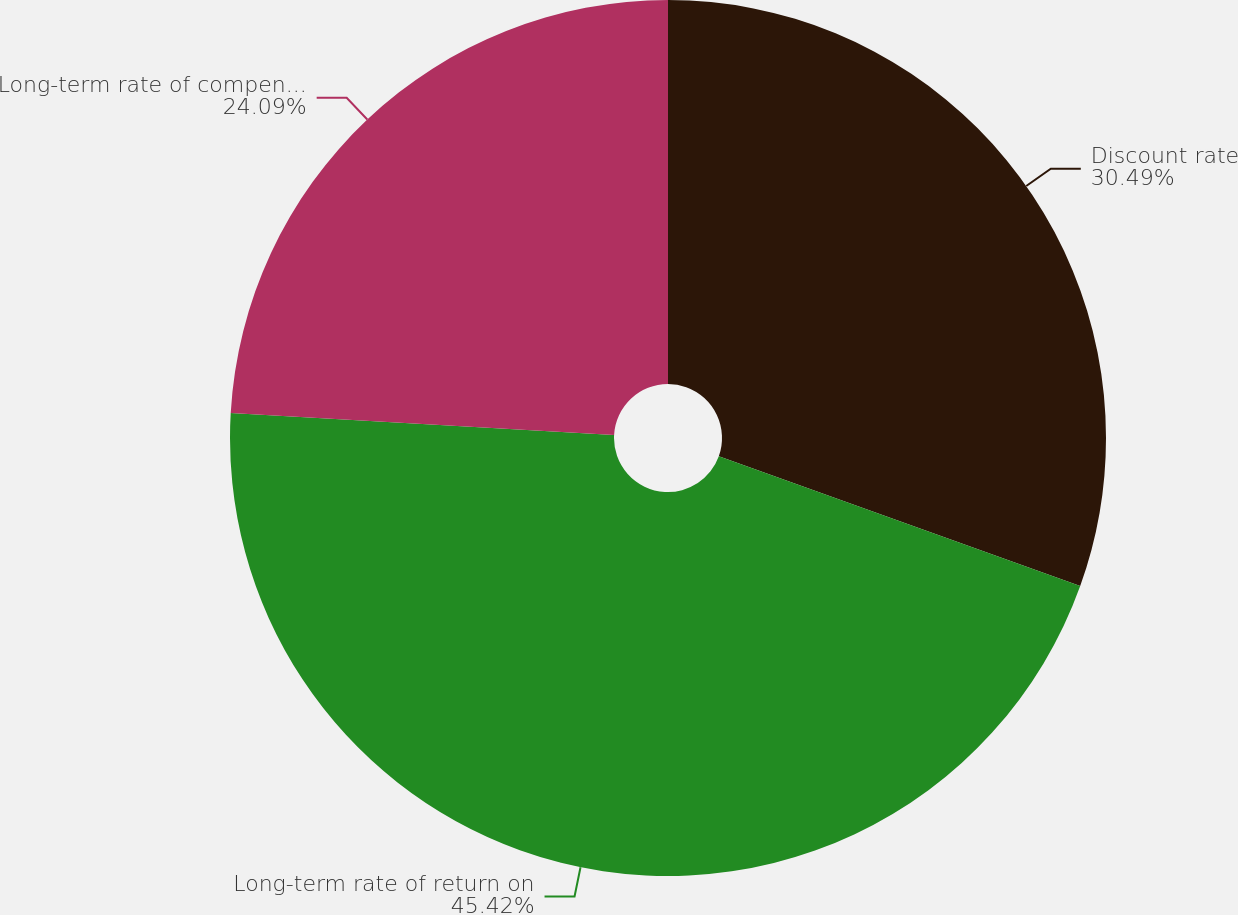<chart> <loc_0><loc_0><loc_500><loc_500><pie_chart><fcel>Discount rate<fcel>Long-term rate of return on<fcel>Long-term rate of compensation<nl><fcel>30.49%<fcel>45.42%<fcel>24.09%<nl></chart> 